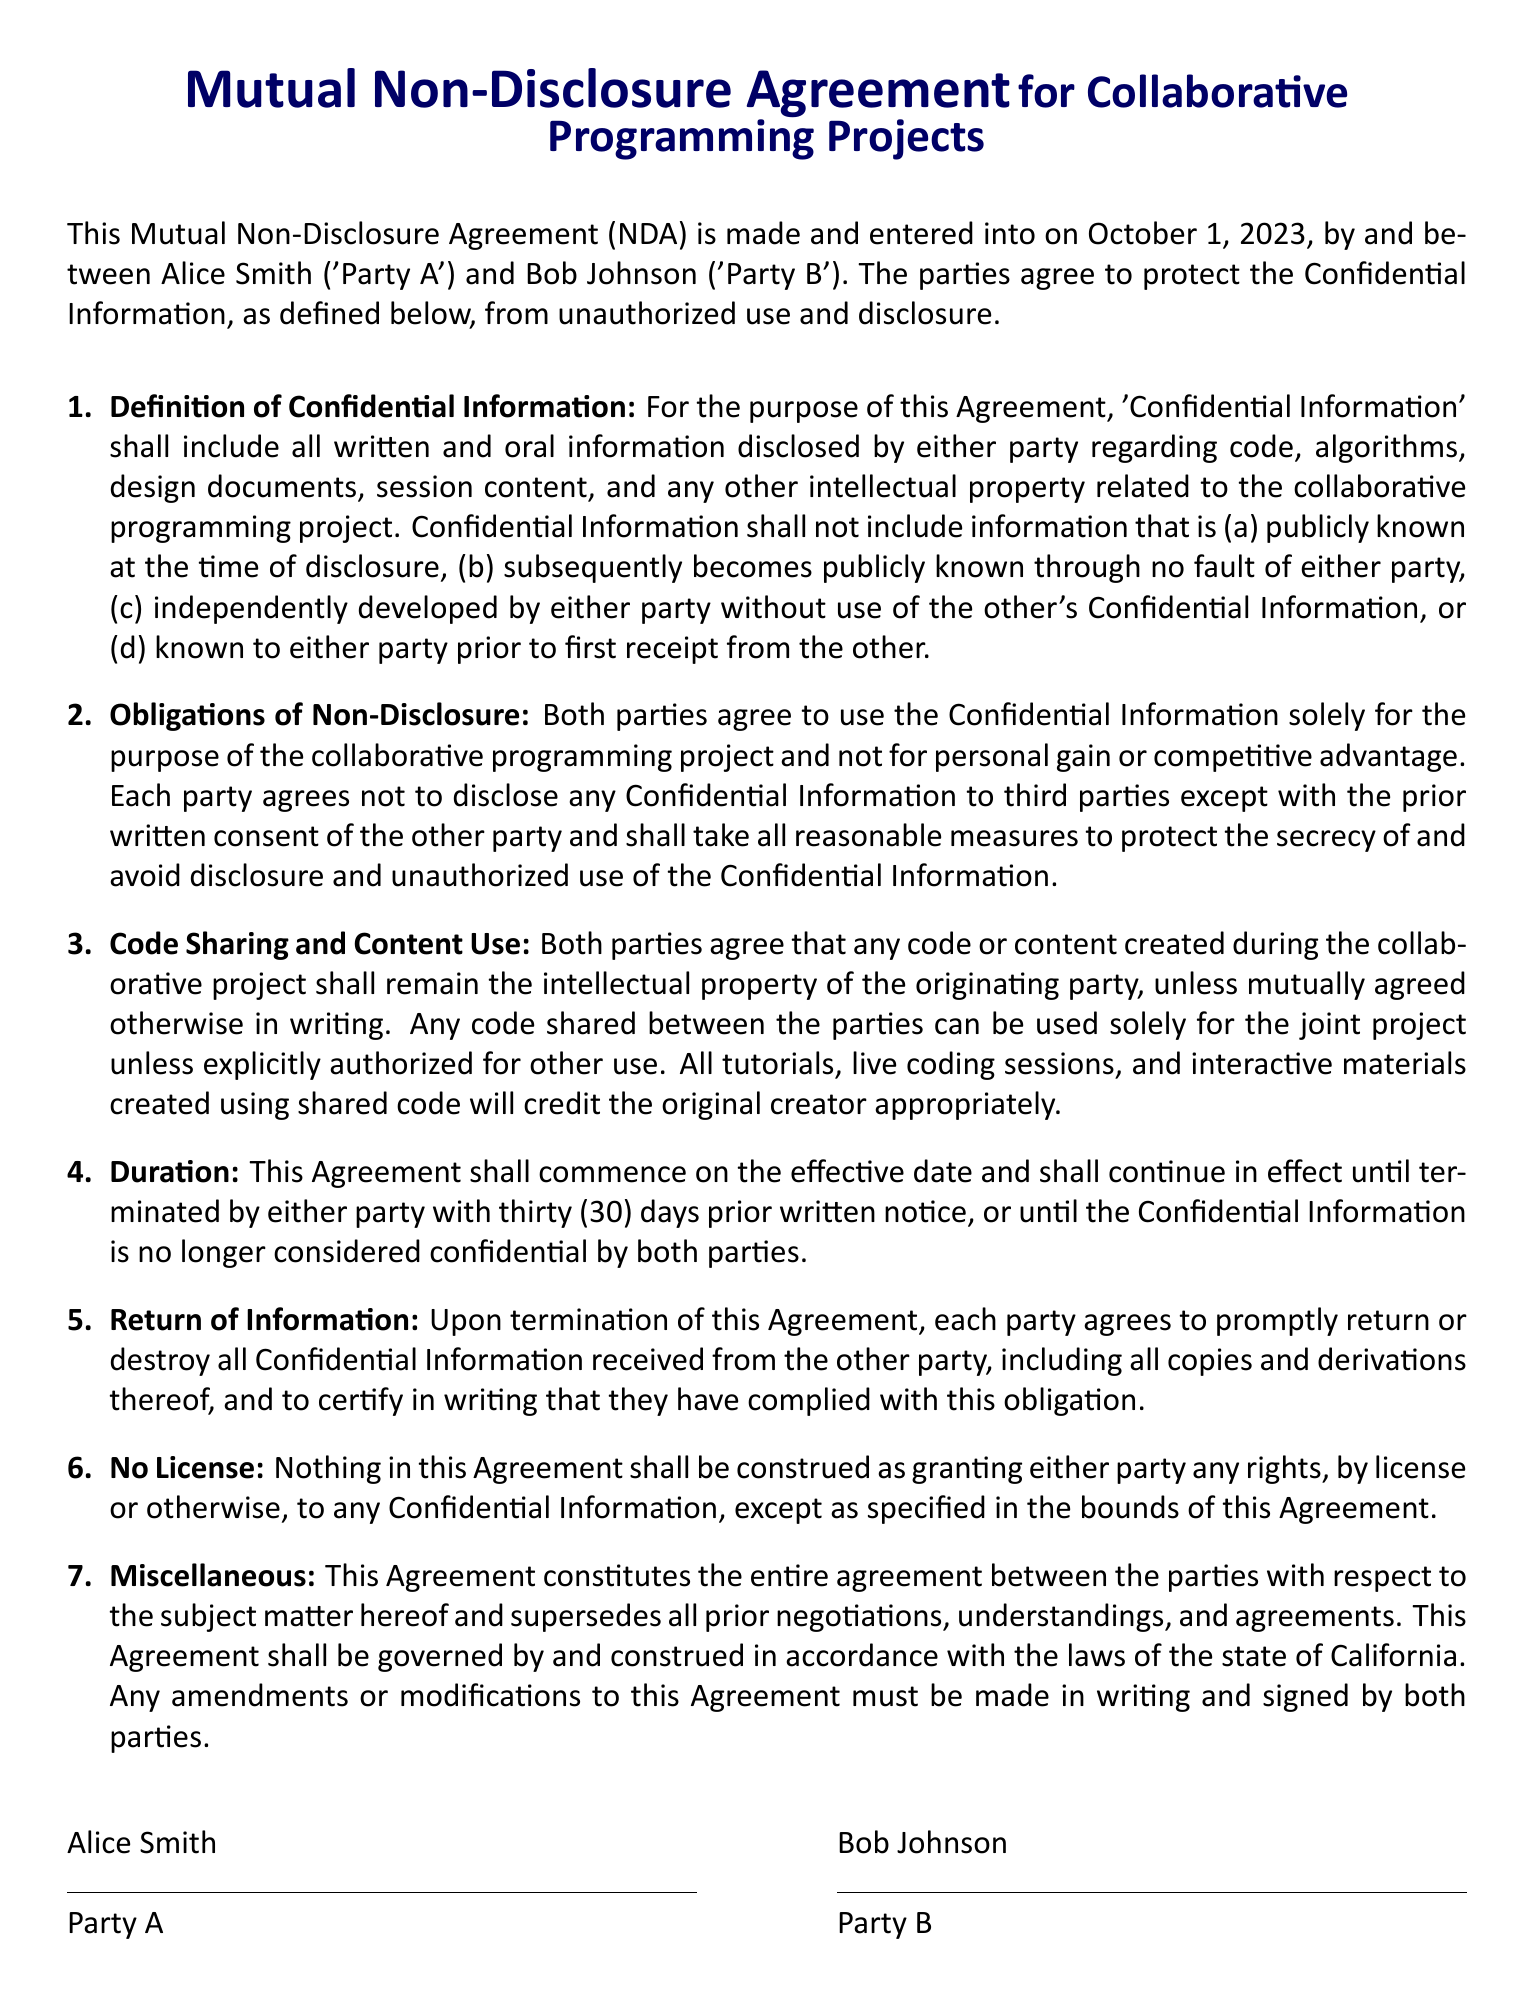What is the effective date of the agreement? The effective date is explicitly mentioned in the agreement as October 1, 2023.
Answer: October 1, 2023 Who are the parties involved in this agreement? The agreement specifies the names of the parties as Alice Smith and Bob Johnson.
Answer: Alice Smith and Bob Johnson What is included in the definition of Confidential Information? The document states that Confidential Information includes code, algorithms, design documents, and session content.
Answer: Code, algorithms, design documents, session content How many days' notice is required for termination of the agreement? The agreement specifies that either party must provide thirty (30) days prior written notice for termination.
Answer: Thirty (30) days What must parties do with Confidential Information upon termination? The agreement states that parties must return or destroy all Confidential Information received from each other.
Answer: Return or destroy What is the governing law for this agreement? The document mentions that the agreement shall be governed by the laws of the state of California.
Answer: State of California What should parties do if they wish to modify the agreement? The document states that any amendments must be made in writing and signed by both parties.
Answer: In writing and signed What is the title of this document? The title is clearly indicated at the top of the document as "Mutual Non-Disclosure Agreement for Collaborative Programming Projects."
Answer: Mutual Non-Disclosure Agreement for Collaborative Programming Projects 